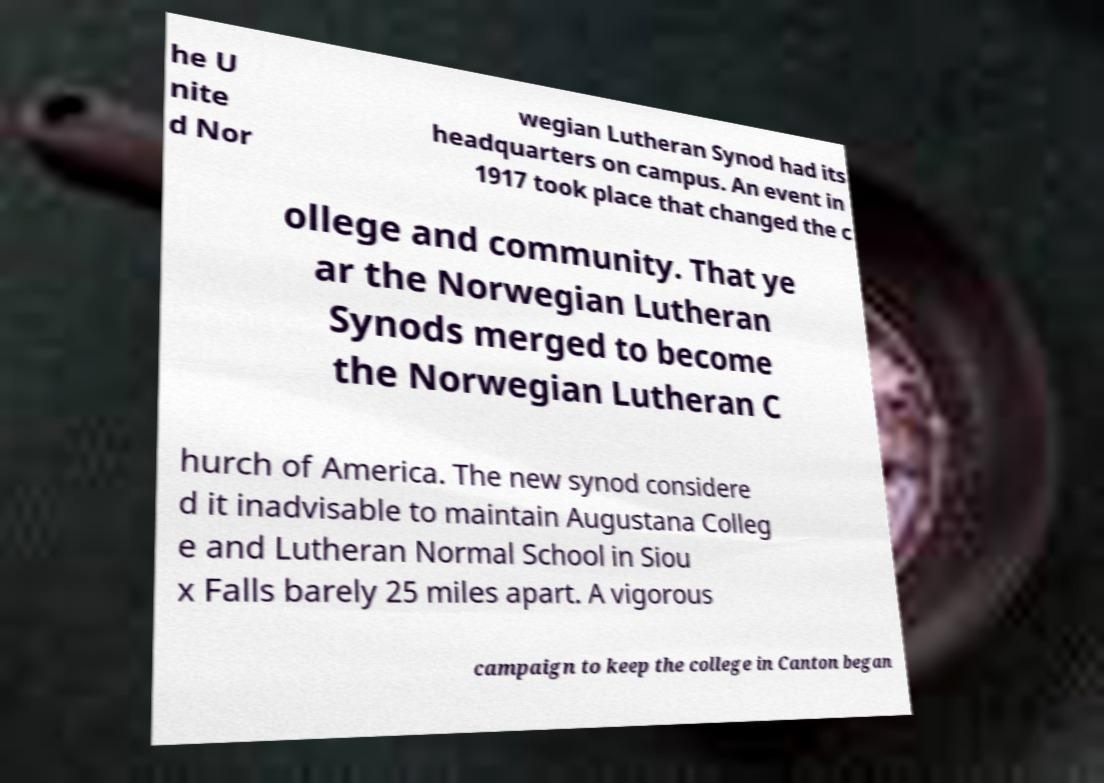Can you accurately transcribe the text from the provided image for me? he U nite d Nor wegian Lutheran Synod had its headquarters on campus. An event in 1917 took place that changed the c ollege and community. That ye ar the Norwegian Lutheran Synods merged to become the Norwegian Lutheran C hurch of America. The new synod considere d it inadvisable to maintain Augustana Colleg e and Lutheran Normal School in Siou x Falls barely 25 miles apart. A vigorous campaign to keep the college in Canton began 